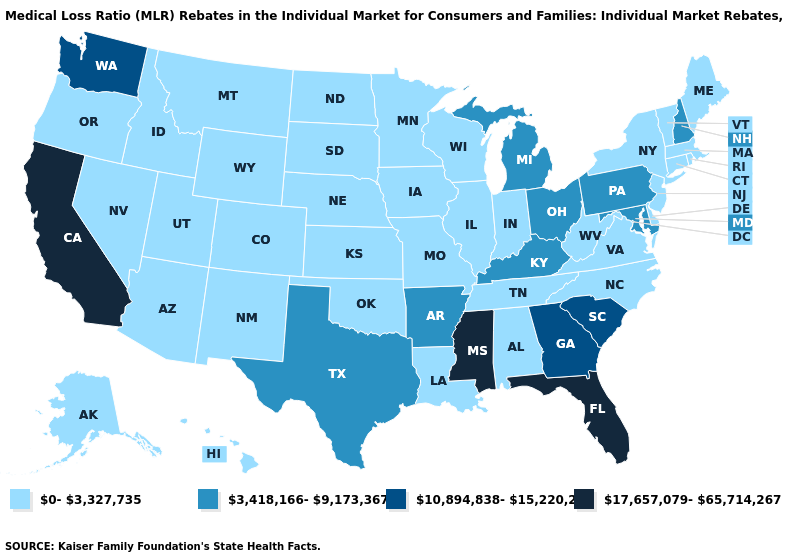Does the map have missing data?
Answer briefly. No. Among the states that border New Mexico , which have the lowest value?
Concise answer only. Arizona, Colorado, Oklahoma, Utah. What is the value of Delaware?
Answer briefly. 0-3,327,735. Name the states that have a value in the range 10,894,838-15,220,279?
Keep it brief. Georgia, South Carolina, Washington. Among the states that border Maryland , does West Virginia have the lowest value?
Short answer required. Yes. What is the lowest value in states that border North Carolina?
Short answer required. 0-3,327,735. Does California have the highest value in the USA?
Write a very short answer. Yes. Among the states that border Idaho , does Washington have the highest value?
Concise answer only. Yes. What is the highest value in the USA?
Answer briefly. 17,657,079-65,714,267. Does Illinois have the lowest value in the MidWest?
Short answer required. Yes. Is the legend a continuous bar?
Keep it brief. No. Among the states that border Massachusetts , does New Hampshire have the highest value?
Be succinct. Yes. What is the highest value in states that border Montana?
Quick response, please. 0-3,327,735. Among the states that border Arkansas , which have the lowest value?
Short answer required. Louisiana, Missouri, Oklahoma, Tennessee. Does Pennsylvania have the highest value in the Northeast?
Concise answer only. Yes. 